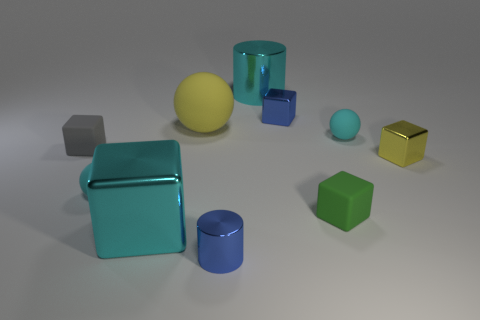Subtract all tiny gray cubes. How many cubes are left? 4 Subtract all blue blocks. How many blocks are left? 4 Subtract 1 cubes. How many cubes are left? 4 Subtract all purple blocks. Subtract all cyan cylinders. How many blocks are left? 5 Subtract all spheres. How many objects are left? 7 Add 1 green rubber objects. How many green rubber objects are left? 2 Add 9 blue metallic cylinders. How many blue metallic cylinders exist? 10 Subtract 0 yellow cylinders. How many objects are left? 10 Subtract all cyan cubes. Subtract all blue blocks. How many objects are left? 8 